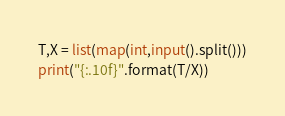<code> <loc_0><loc_0><loc_500><loc_500><_Python_>T,X = list(map(int,input().split()))
print("{:.10f}".format(T/X))
</code> 